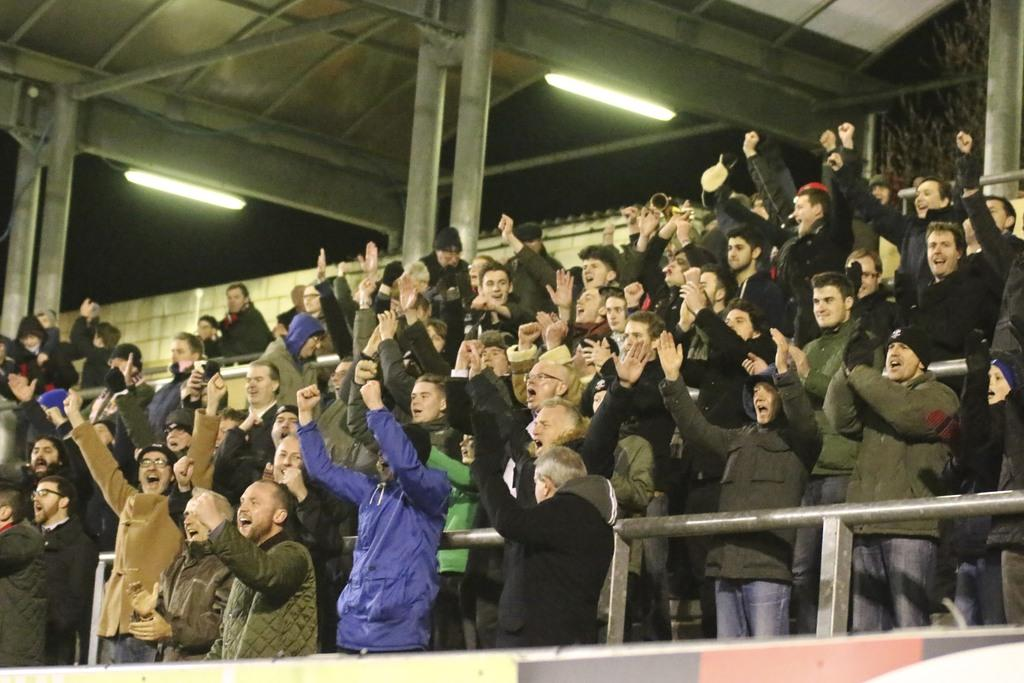What can be seen in the image? There is a group of audience in the image. How are the audience behaving? The audience is standing and shouting. What type of structure is visible in the image? There is an iron frame visible in the image. Can you describe the lighting in the image? There is a shed with tube lights in the image. What type of guide can be seen assisting patients in the image? There is no guide or patients present in the image; it features a group of audience and an iron frame. What type of structure is the hospital in the image? There is no hospital or structure related to a hospital mentioned in the image; it only features a group of audience, an iron frame, and a shed with tube lights. 